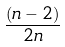Convert formula to latex. <formula><loc_0><loc_0><loc_500><loc_500>\frac { ( n - 2 ) } { 2 n }</formula> 